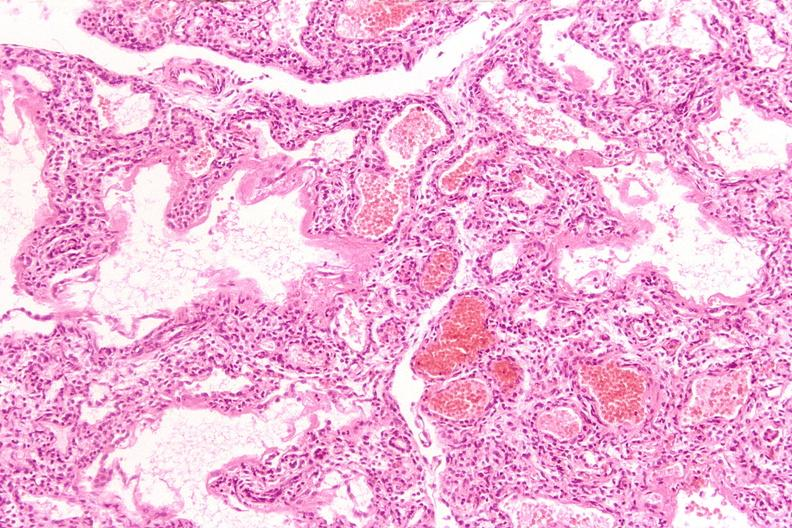does cryptosporidia show lungs, hyaline membrane disease?
Answer the question using a single word or phrase. No 